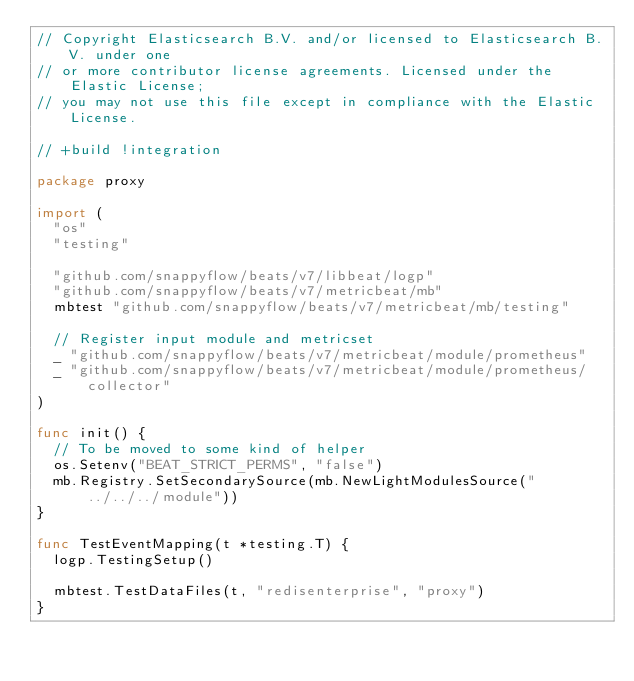Convert code to text. <code><loc_0><loc_0><loc_500><loc_500><_Go_>// Copyright Elasticsearch B.V. and/or licensed to Elasticsearch B.V. under one
// or more contributor license agreements. Licensed under the Elastic License;
// you may not use this file except in compliance with the Elastic License.

// +build !integration

package proxy

import (
	"os"
	"testing"

	"github.com/snappyflow/beats/v7/libbeat/logp"
	"github.com/snappyflow/beats/v7/metricbeat/mb"
	mbtest "github.com/snappyflow/beats/v7/metricbeat/mb/testing"

	// Register input module and metricset
	_ "github.com/snappyflow/beats/v7/metricbeat/module/prometheus"
	_ "github.com/snappyflow/beats/v7/metricbeat/module/prometheus/collector"
)

func init() {
	// To be moved to some kind of helper
	os.Setenv("BEAT_STRICT_PERMS", "false")
	mb.Registry.SetSecondarySource(mb.NewLightModulesSource("../../../module"))
}

func TestEventMapping(t *testing.T) {
	logp.TestingSetup()

	mbtest.TestDataFiles(t, "redisenterprise", "proxy")
}
</code> 